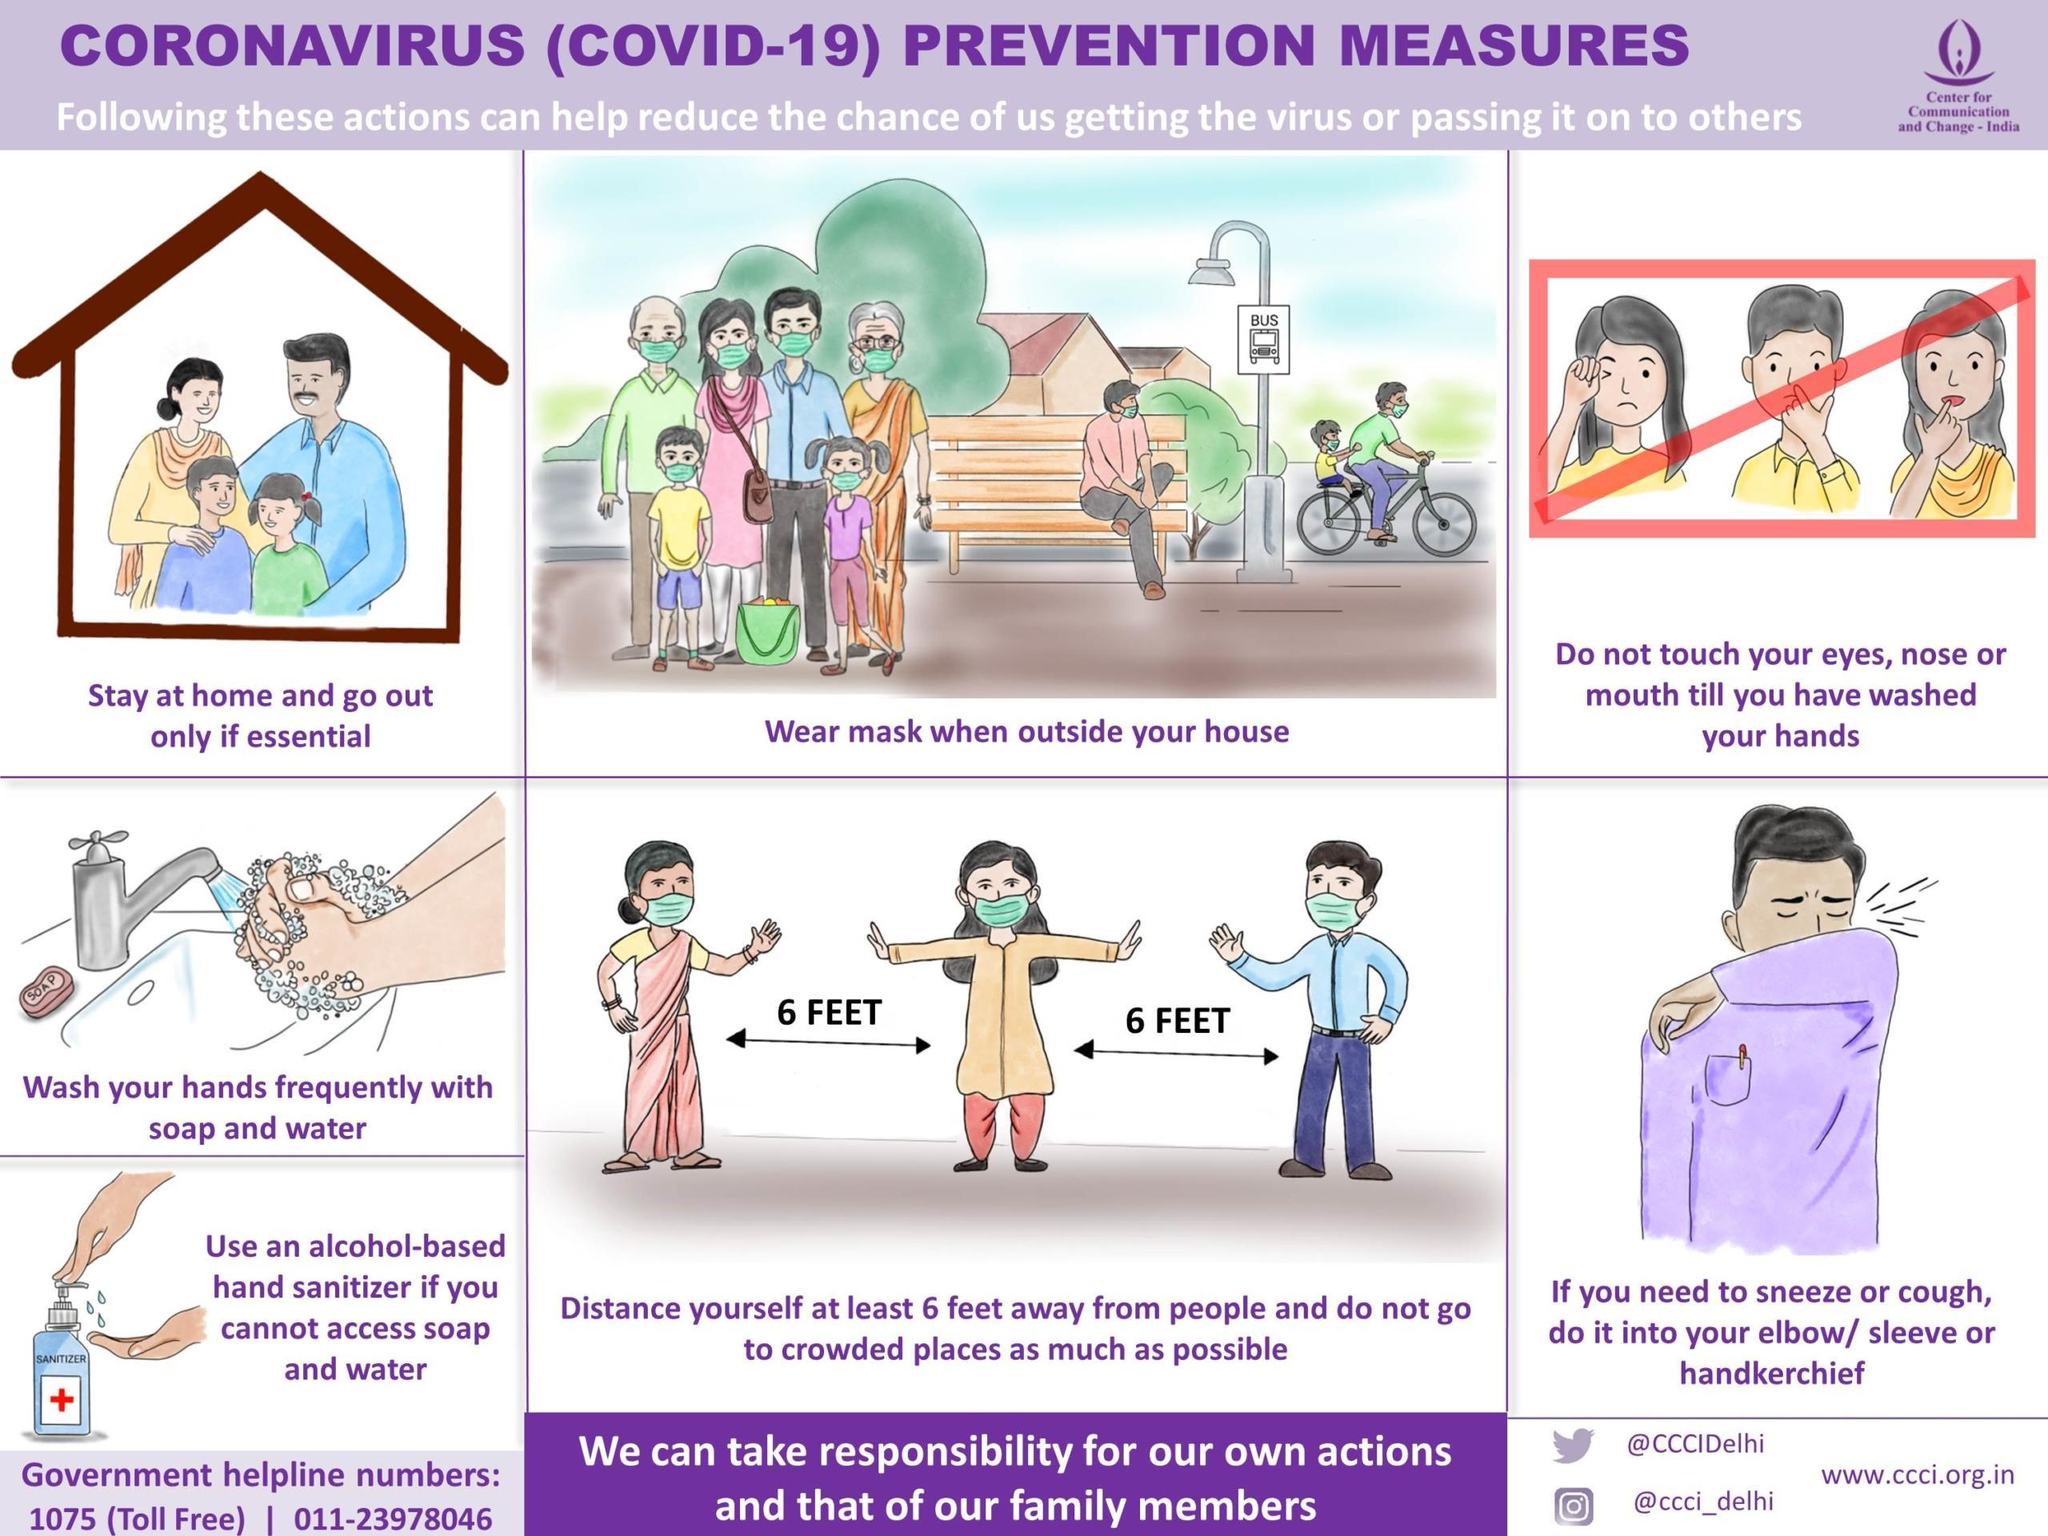How many measures are in this infographic to prevent coronavirus?
Answer the question with a short phrase. 7 What are the parts of the face? eyes, nose, mouth How many bottles of sanitizer are in this infographic? 1 